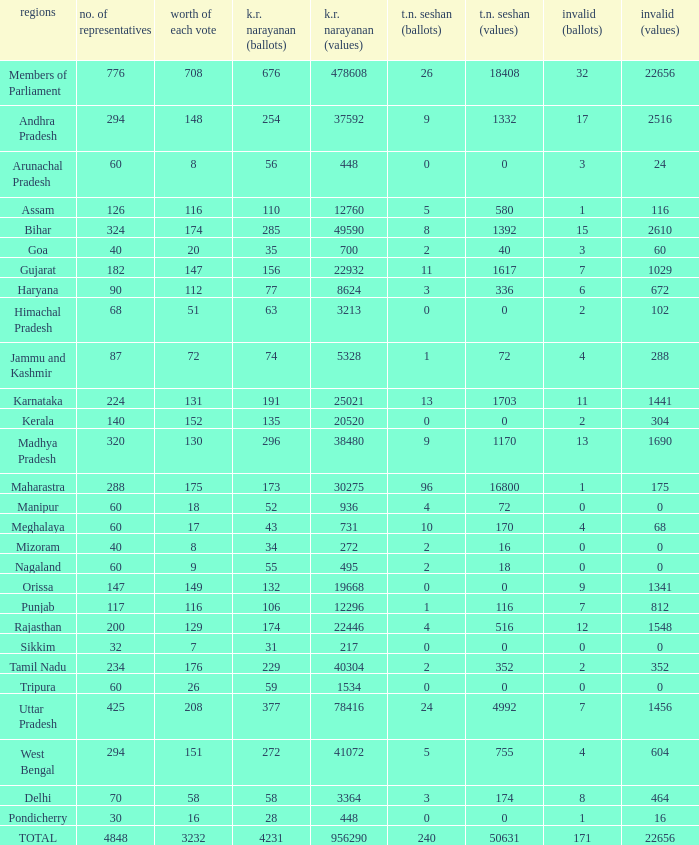Name the k. r. narayanan values for pondicherry 448.0. 